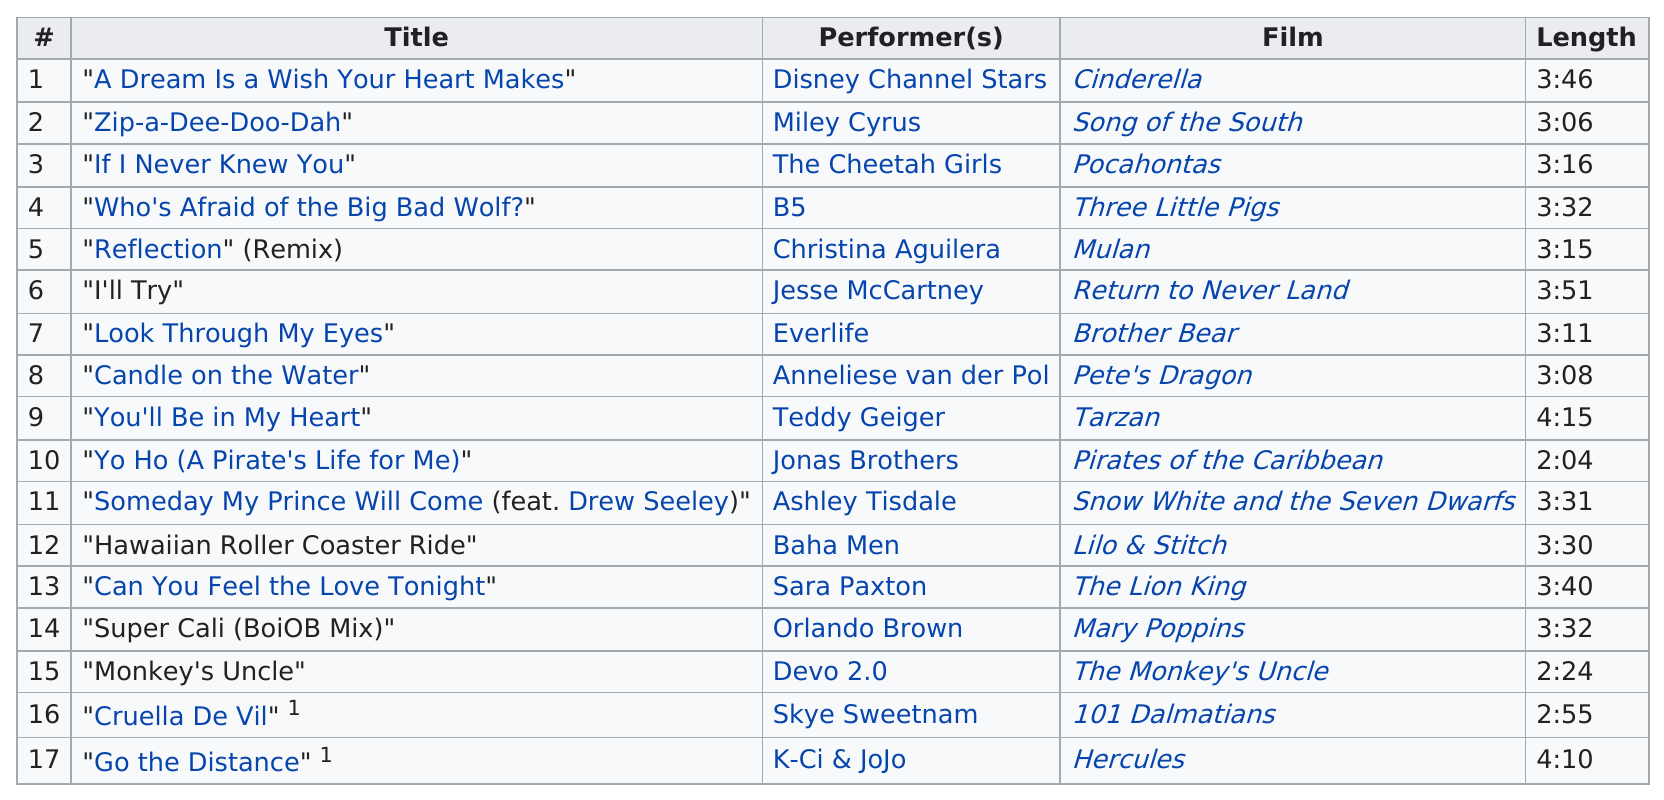Specify some key components in this picture. The song 'Can You Feel the Love Tonight' or 'Candle on the Water' from the Lion King is a declaration of love. There are two songs that are longer than four minutes. After the song "Cruella de Vil?", the next song is "Go the Distance". The song that comes consecutively after song 5 is 'I'll Try'. The duration of the song 'Look Through My Eyes' by Everlife is 3 minutes and 11 seconds. 